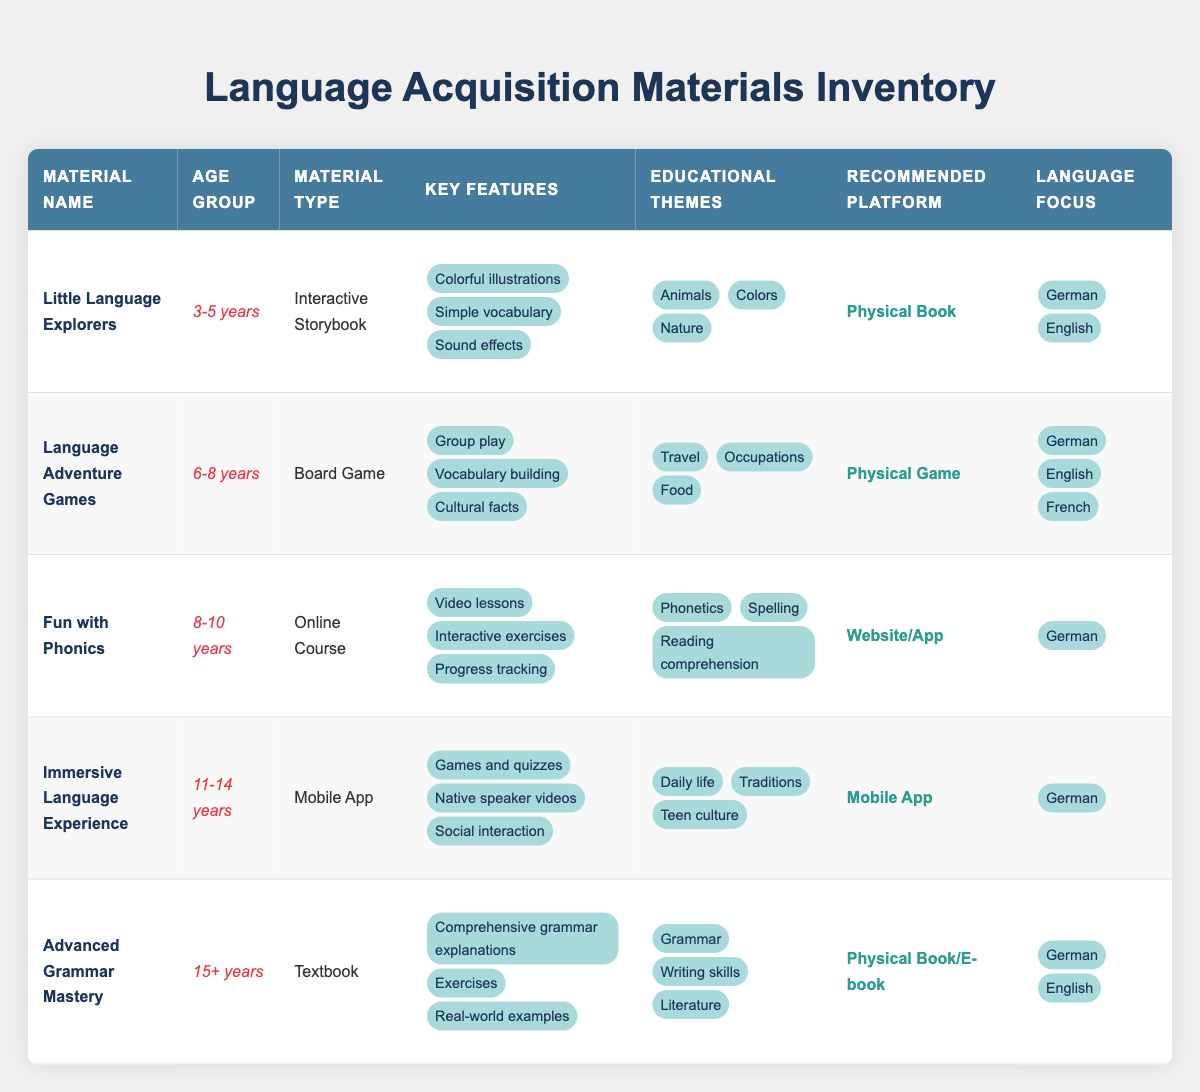What is the age group for "Little Language Explorers"? The table lists "Little Language Explorers" under the age group column, showing that it is designed for children aged 3-5 years.
Answer: 3-5 years Which material focuses on the educational theme of "Grammar"? By reviewing the educational themes for each material, "Advanced Grammar Mastery" is the only one explicitly stating "Grammar" as a theme.
Answer: Advanced Grammar Mastery How many language focuses does the "Language Adventure Games" include? The "Language Adventure Games" material shows three language focuses: German, English, and French, which can be counted directly from the table.
Answer: 3 Does "Fun with Phonics" include any language focus other than German? The table indicates that "Fun with Phonics" exclusively focuses on German, as no other languages are listed under the language focus column for this material.
Answer: No Which material type has the most key features? By counting the key features listed, "Advanced Grammar Mastery" has the most features (3), while "Little Language Explorers," "Language Adventure Games," "Fun with Phonics," and "Immersive Language Experience" also have 3. Therefore, multiple materials tie for the most key features.
Answer: 3 (multiple materials) What is the recommended platform for "Immersive Language Experience" and what is its age group? The row for "Immersive Language Experience" specifies that its recommended platform is a "Mobile App" and it is aimed at the age group 11-14 years.
Answer: Mobile App, 11-14 years Which educational themes are found in both "Language Adventure Games" and "Little Language Explorers"? Upon examining both materials, "Travel," "Occupations," and "Food" are listed under "Language Adventure Games," while "Animals," "Colors," and "Nature" are mentioned for "Little Language Explorers," with no overlapping themes found.
Answer: None How does the material "Advanced Grammar Mastery" compare to "Fun with Phonics" in terms of material type and age group? "Advanced Grammar Mastery" is a textbook for ages 15+, while "Fun with Phonics" is an online course for ages 8-10 years. Thus, they differ in both material type and target age group.
Answer: Different material types and age groups What percentage of the materials are available as physical books? Out of the five materials, two are listed as physical books: "Little Language Explorers" and "Advanced Grammar Mastery." Calculating this gives (2/5) * 100% = 40%.
Answer: 40% 